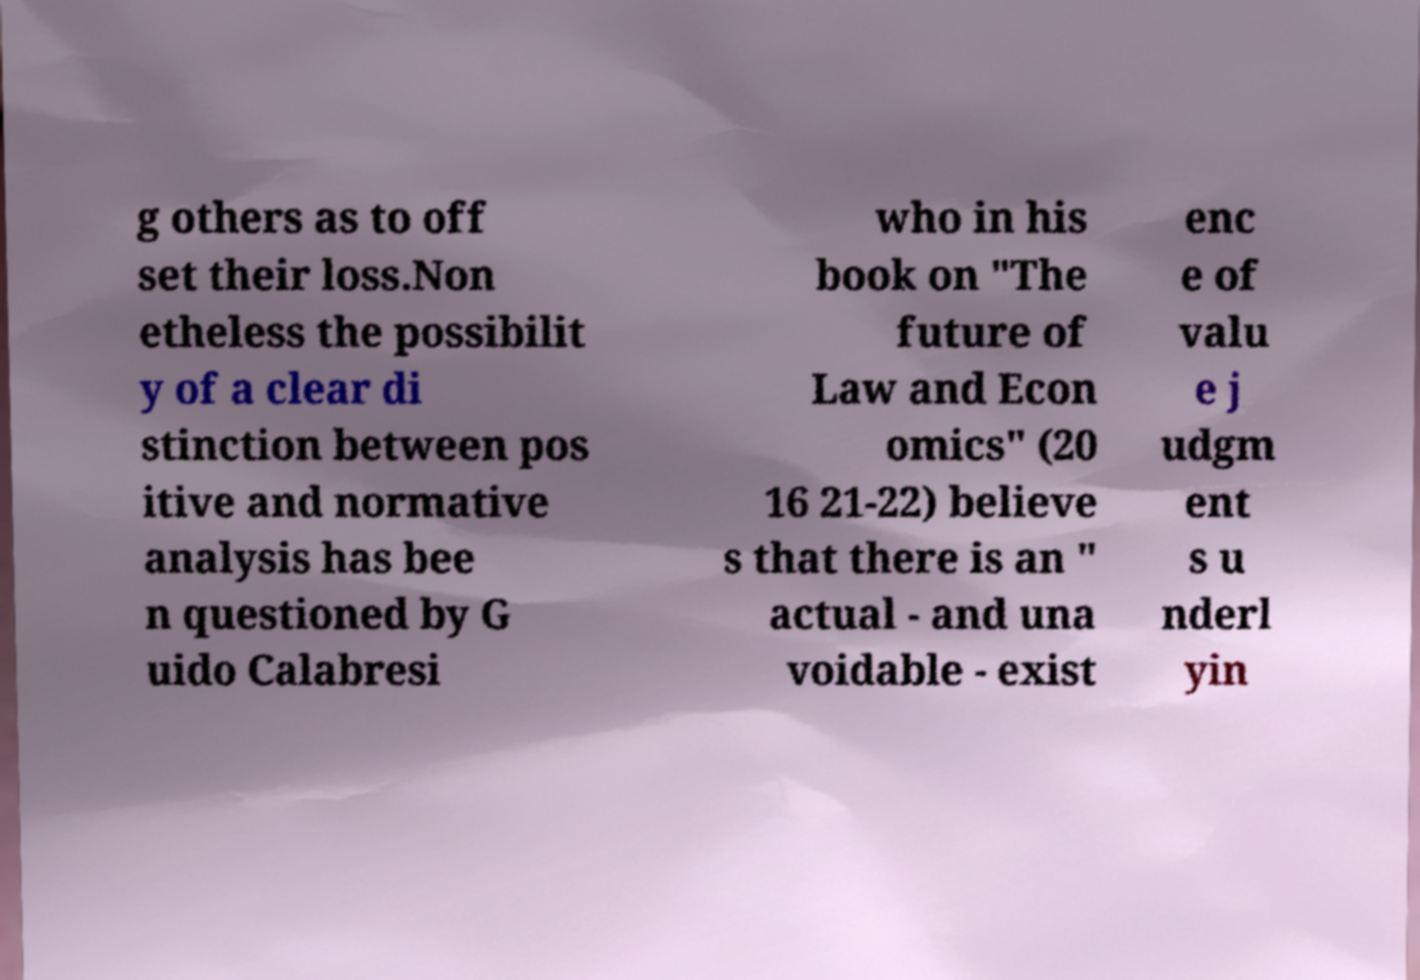For documentation purposes, I need the text within this image transcribed. Could you provide that? g others as to off set their loss.Non etheless the possibilit y of a clear di stinction between pos itive and normative analysis has bee n questioned by G uido Calabresi who in his book on "The future of Law and Econ omics" (20 16 21-22) believe s that there is an " actual - and una voidable - exist enc e of valu e j udgm ent s u nderl yin 